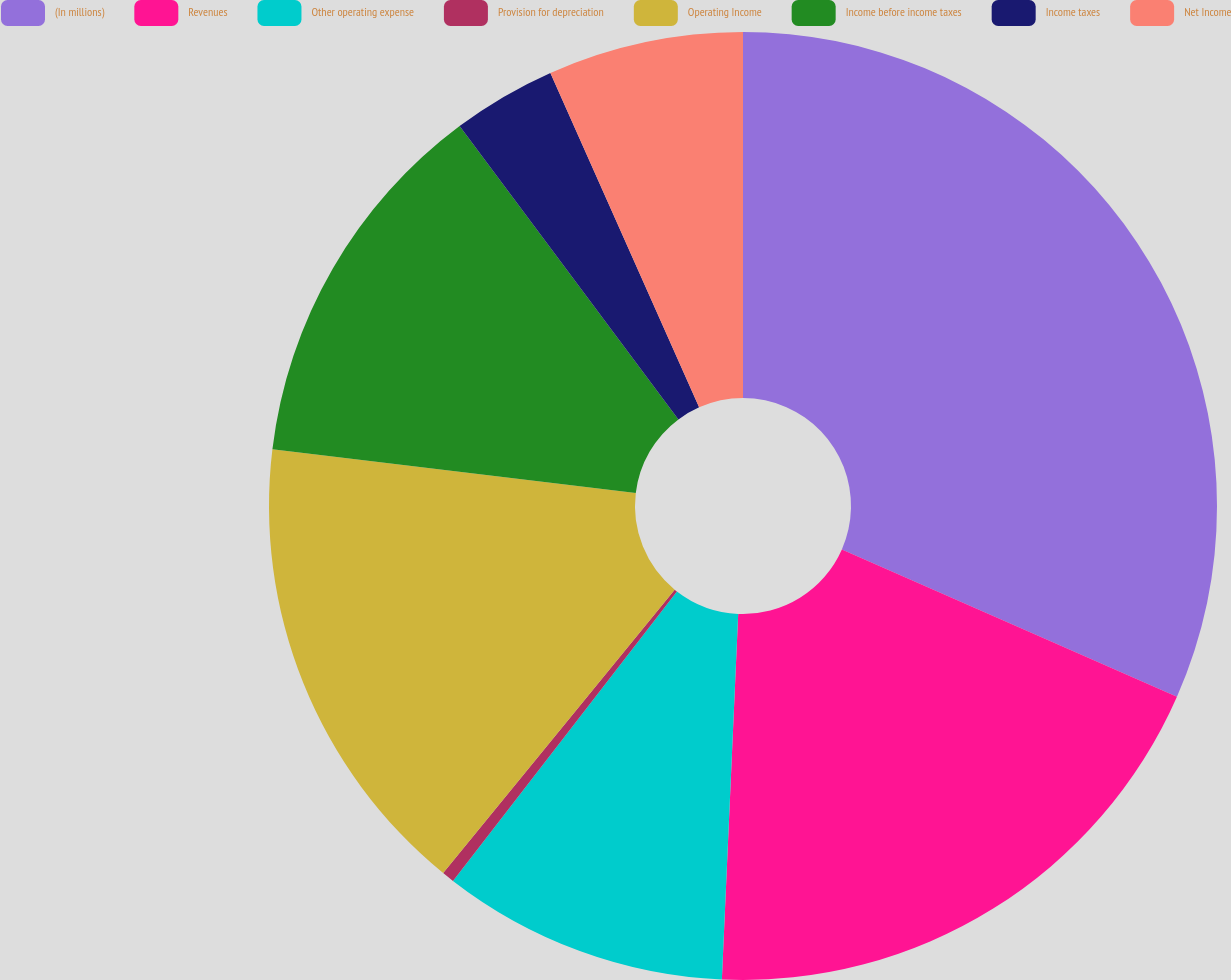Convert chart. <chart><loc_0><loc_0><loc_500><loc_500><pie_chart><fcel>(In millions)<fcel>Revenues<fcel>Other operating expense<fcel>Provision for depreciation<fcel>Operating Income<fcel>Income before income taxes<fcel>Income taxes<fcel>Net Income<nl><fcel>31.59%<fcel>19.12%<fcel>9.77%<fcel>0.42%<fcel>16.01%<fcel>12.89%<fcel>3.54%<fcel>6.66%<nl></chart> 